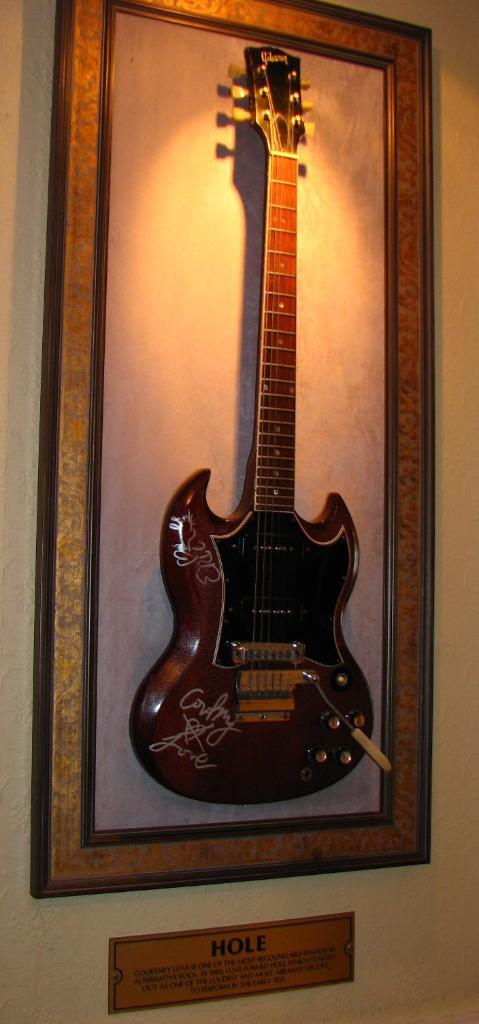Provide a one-sentence caption for the provided image. Framed guitar that has a sign below it that says HOLE. 